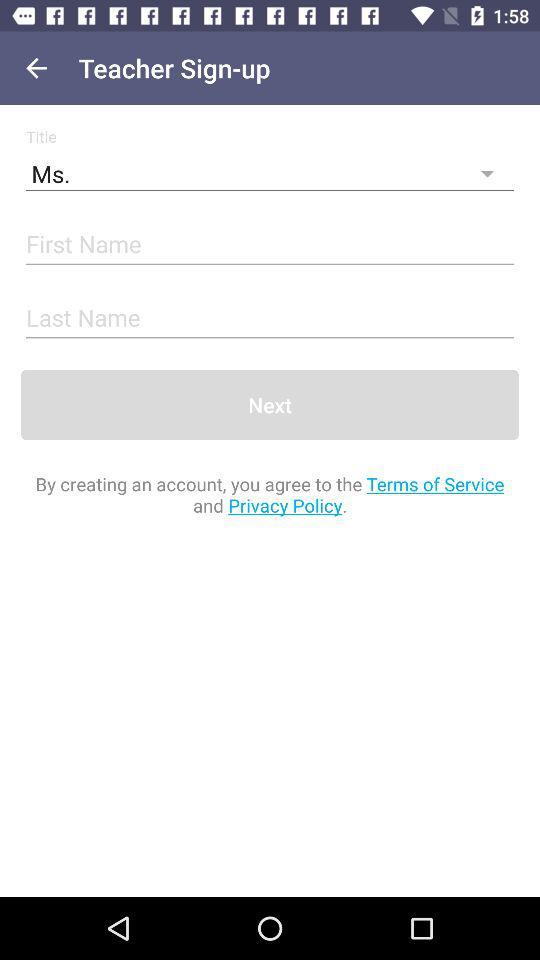How many text inputs are required to create an account?
Answer the question using a single word or phrase. 2 